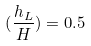<formula> <loc_0><loc_0><loc_500><loc_500>( \frac { h _ { L } } { H } ) = 0 . 5</formula> 